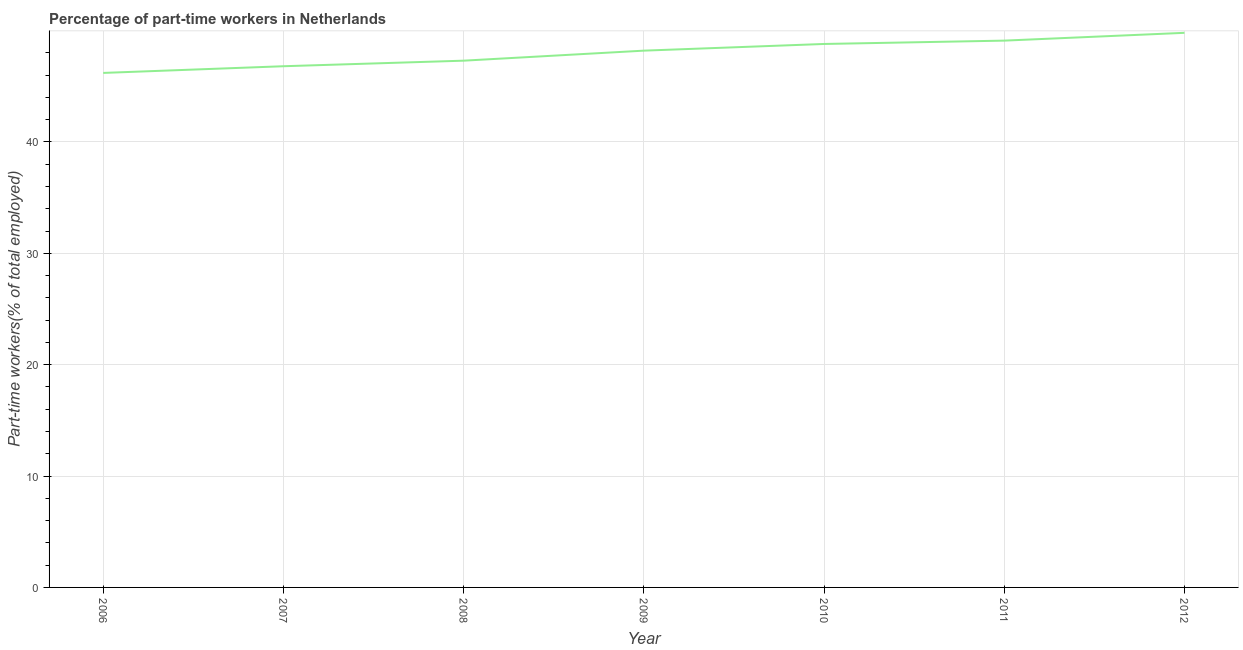What is the percentage of part-time workers in 2010?
Keep it short and to the point. 48.8. Across all years, what is the maximum percentage of part-time workers?
Give a very brief answer. 49.8. Across all years, what is the minimum percentage of part-time workers?
Provide a short and direct response. 46.2. In which year was the percentage of part-time workers minimum?
Provide a short and direct response. 2006. What is the sum of the percentage of part-time workers?
Offer a terse response. 336.2. What is the average percentage of part-time workers per year?
Your answer should be compact. 48.03. What is the median percentage of part-time workers?
Your response must be concise. 48.2. In how many years, is the percentage of part-time workers greater than 38 %?
Provide a succinct answer. 7. What is the ratio of the percentage of part-time workers in 2006 to that in 2008?
Make the answer very short. 0.98. Is the difference between the percentage of part-time workers in 2006 and 2010 greater than the difference between any two years?
Provide a short and direct response. No. What is the difference between the highest and the second highest percentage of part-time workers?
Provide a succinct answer. 0.7. What is the difference between the highest and the lowest percentage of part-time workers?
Ensure brevity in your answer.  3.6. Does the percentage of part-time workers monotonically increase over the years?
Your response must be concise. Yes. How many lines are there?
Your answer should be very brief. 1. How many years are there in the graph?
Keep it short and to the point. 7. What is the difference between two consecutive major ticks on the Y-axis?
Provide a succinct answer. 10. Are the values on the major ticks of Y-axis written in scientific E-notation?
Your answer should be very brief. No. Does the graph contain grids?
Ensure brevity in your answer.  Yes. What is the title of the graph?
Make the answer very short. Percentage of part-time workers in Netherlands. What is the label or title of the X-axis?
Your answer should be very brief. Year. What is the label or title of the Y-axis?
Give a very brief answer. Part-time workers(% of total employed). What is the Part-time workers(% of total employed) of 2006?
Provide a short and direct response. 46.2. What is the Part-time workers(% of total employed) of 2007?
Make the answer very short. 46.8. What is the Part-time workers(% of total employed) in 2008?
Provide a short and direct response. 47.3. What is the Part-time workers(% of total employed) of 2009?
Your answer should be compact. 48.2. What is the Part-time workers(% of total employed) of 2010?
Your answer should be very brief. 48.8. What is the Part-time workers(% of total employed) of 2011?
Ensure brevity in your answer.  49.1. What is the Part-time workers(% of total employed) of 2012?
Offer a very short reply. 49.8. What is the difference between the Part-time workers(% of total employed) in 2007 and 2008?
Make the answer very short. -0.5. What is the difference between the Part-time workers(% of total employed) in 2007 and 2010?
Offer a very short reply. -2. What is the difference between the Part-time workers(% of total employed) in 2007 and 2011?
Offer a very short reply. -2.3. What is the difference between the Part-time workers(% of total employed) in 2008 and 2009?
Ensure brevity in your answer.  -0.9. What is the difference between the Part-time workers(% of total employed) in 2008 and 2010?
Offer a terse response. -1.5. What is the difference between the Part-time workers(% of total employed) in 2008 and 2011?
Your answer should be very brief. -1.8. What is the difference between the Part-time workers(% of total employed) in 2008 and 2012?
Keep it short and to the point. -2.5. What is the difference between the Part-time workers(% of total employed) in 2009 and 2010?
Keep it short and to the point. -0.6. What is the difference between the Part-time workers(% of total employed) in 2009 and 2011?
Provide a succinct answer. -0.9. What is the ratio of the Part-time workers(% of total employed) in 2006 to that in 2007?
Provide a short and direct response. 0.99. What is the ratio of the Part-time workers(% of total employed) in 2006 to that in 2009?
Give a very brief answer. 0.96. What is the ratio of the Part-time workers(% of total employed) in 2006 to that in 2010?
Provide a succinct answer. 0.95. What is the ratio of the Part-time workers(% of total employed) in 2006 to that in 2011?
Offer a very short reply. 0.94. What is the ratio of the Part-time workers(% of total employed) in 2006 to that in 2012?
Your answer should be very brief. 0.93. What is the ratio of the Part-time workers(% of total employed) in 2007 to that in 2008?
Your answer should be very brief. 0.99. What is the ratio of the Part-time workers(% of total employed) in 2007 to that in 2010?
Your response must be concise. 0.96. What is the ratio of the Part-time workers(% of total employed) in 2007 to that in 2011?
Your answer should be compact. 0.95. What is the ratio of the Part-time workers(% of total employed) in 2007 to that in 2012?
Your response must be concise. 0.94. What is the ratio of the Part-time workers(% of total employed) in 2008 to that in 2009?
Your answer should be very brief. 0.98. What is the ratio of the Part-time workers(% of total employed) in 2008 to that in 2010?
Keep it short and to the point. 0.97. What is the ratio of the Part-time workers(% of total employed) in 2009 to that in 2011?
Ensure brevity in your answer.  0.98. What is the ratio of the Part-time workers(% of total employed) in 2011 to that in 2012?
Your response must be concise. 0.99. 